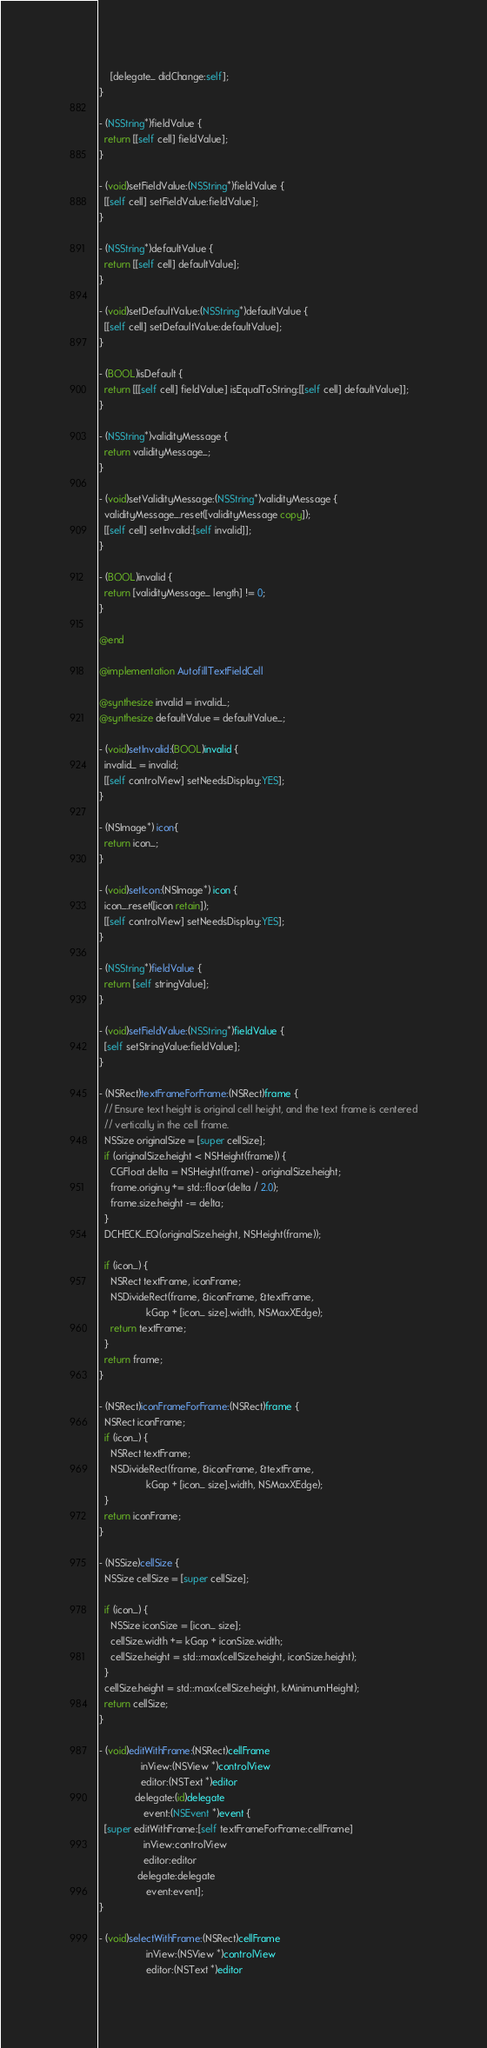Convert code to text. <code><loc_0><loc_0><loc_500><loc_500><_ObjectiveC_>    [delegate_ didChange:self];
}

- (NSString*)fieldValue {
  return [[self cell] fieldValue];
}

- (void)setFieldValue:(NSString*)fieldValue {
  [[self cell] setFieldValue:fieldValue];
}

- (NSString*)defaultValue {
  return [[self cell] defaultValue];
}

- (void)setDefaultValue:(NSString*)defaultValue {
  [[self cell] setDefaultValue:defaultValue];
}

- (BOOL)isDefault {
  return [[[self cell] fieldValue] isEqualToString:[[self cell] defaultValue]];
}

- (NSString*)validityMessage {
  return validityMessage_;
}

- (void)setValidityMessage:(NSString*)validityMessage {
  validityMessage_.reset([validityMessage copy]);
  [[self cell] setInvalid:[self invalid]];
}

- (BOOL)invalid {
  return [validityMessage_ length] != 0;
}

@end

@implementation AutofillTextFieldCell

@synthesize invalid = invalid_;
@synthesize defaultValue = defaultValue_;

- (void)setInvalid:(BOOL)invalid {
  invalid_ = invalid;
  [[self controlView] setNeedsDisplay:YES];
}

- (NSImage*) icon{
  return icon_;
}

- (void)setIcon:(NSImage*) icon {
  icon_.reset([icon retain]);
  [[self controlView] setNeedsDisplay:YES];
}

- (NSString*)fieldValue {
  return [self stringValue];
}

- (void)setFieldValue:(NSString*)fieldValue {
  [self setStringValue:fieldValue];
}

- (NSRect)textFrameForFrame:(NSRect)frame {
  // Ensure text height is original cell height, and the text frame is centered
  // vertically in the cell frame.
  NSSize originalSize = [super cellSize];
  if (originalSize.height < NSHeight(frame)) {
    CGFloat delta = NSHeight(frame) - originalSize.height;
    frame.origin.y += std::floor(delta / 2.0);
    frame.size.height -= delta;
  }
  DCHECK_EQ(originalSize.height, NSHeight(frame));

  if (icon_) {
    NSRect textFrame, iconFrame;
    NSDivideRect(frame, &iconFrame, &textFrame,
                 kGap + [icon_ size].width, NSMaxXEdge);
    return textFrame;
  }
  return frame;
}

- (NSRect)iconFrameForFrame:(NSRect)frame {
  NSRect iconFrame;
  if (icon_) {
    NSRect textFrame;
    NSDivideRect(frame, &iconFrame, &textFrame,
                 kGap + [icon_ size].width, NSMaxXEdge);
  }
  return iconFrame;
}

- (NSSize)cellSize {
  NSSize cellSize = [super cellSize];

  if (icon_) {
    NSSize iconSize = [icon_ size];
    cellSize.width += kGap + iconSize.width;
    cellSize.height = std::max(cellSize.height, iconSize.height);
  }
  cellSize.height = std::max(cellSize.height, kMinimumHeight);
  return cellSize;
}

- (void)editWithFrame:(NSRect)cellFrame
               inView:(NSView *)controlView
               editor:(NSText *)editor
             delegate:(id)delegate
                event:(NSEvent *)event {
  [super editWithFrame:[self textFrameForFrame:cellFrame]
                inView:controlView
                editor:editor
              delegate:delegate
                 event:event];
}

- (void)selectWithFrame:(NSRect)cellFrame
                 inView:(NSView *)controlView
                 editor:(NSText *)editor</code> 